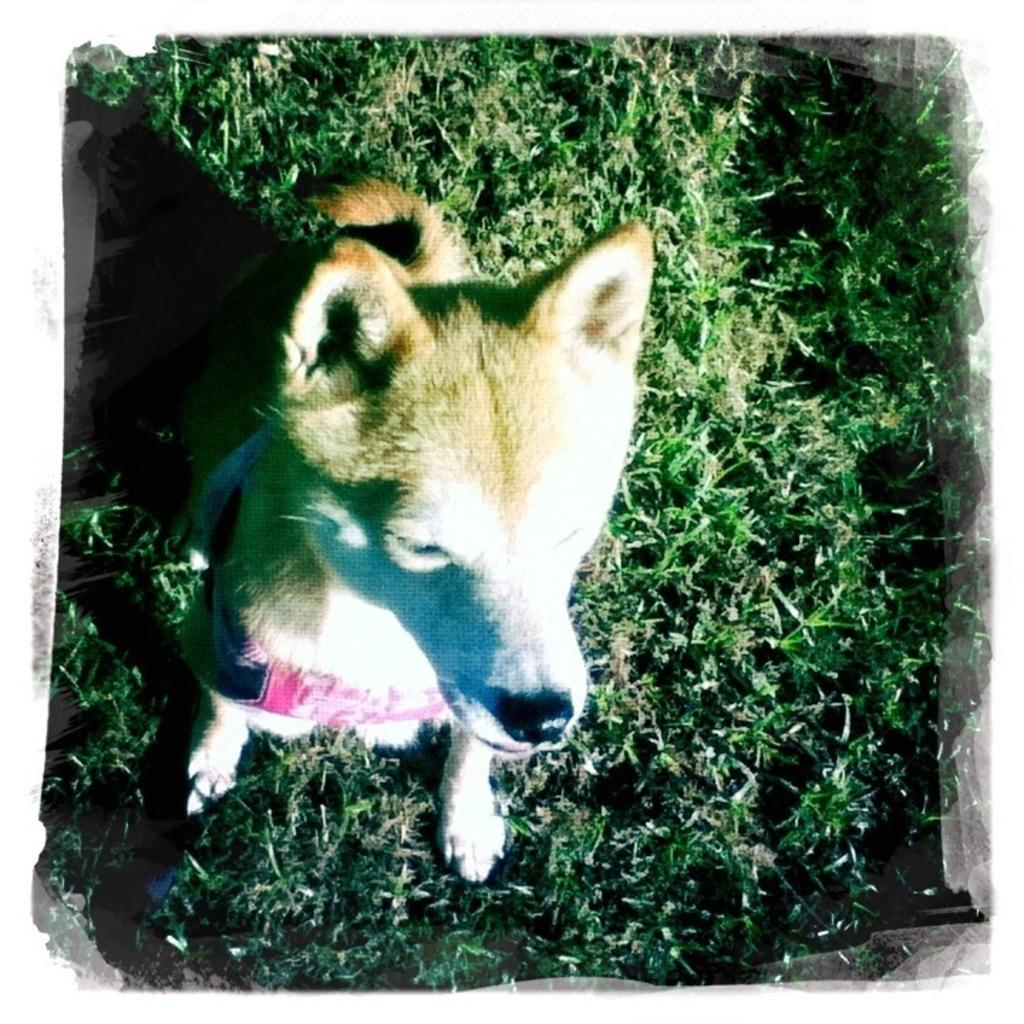Please provide a concise description of this image. In this image, we can see a dog is on the grass. 